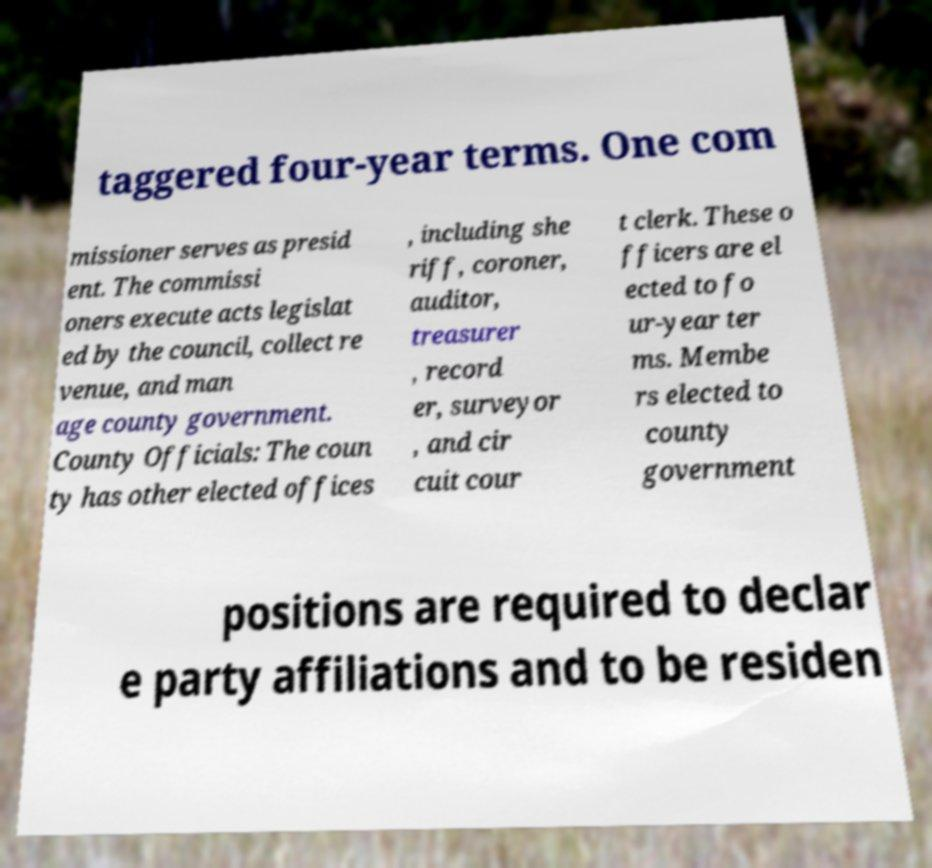I need the written content from this picture converted into text. Can you do that? taggered four-year terms. One com missioner serves as presid ent. The commissi oners execute acts legislat ed by the council, collect re venue, and man age county government. County Officials: The coun ty has other elected offices , including she riff, coroner, auditor, treasurer , record er, surveyor , and cir cuit cour t clerk. These o fficers are el ected to fo ur-year ter ms. Membe rs elected to county government positions are required to declar e party affiliations and to be residen 